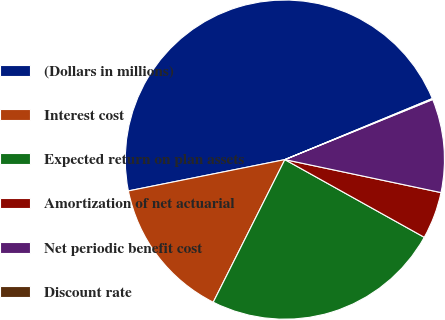Convert chart to OTSL. <chart><loc_0><loc_0><loc_500><loc_500><pie_chart><fcel>(Dollars in millions)<fcel>Interest cost<fcel>Expected return on plan assets<fcel>Amortization of net actuarial<fcel>Net periodic benefit cost<fcel>Discount rate<nl><fcel>46.9%<fcel>14.45%<fcel>24.32%<fcel>4.78%<fcel>9.46%<fcel>0.1%<nl></chart> 